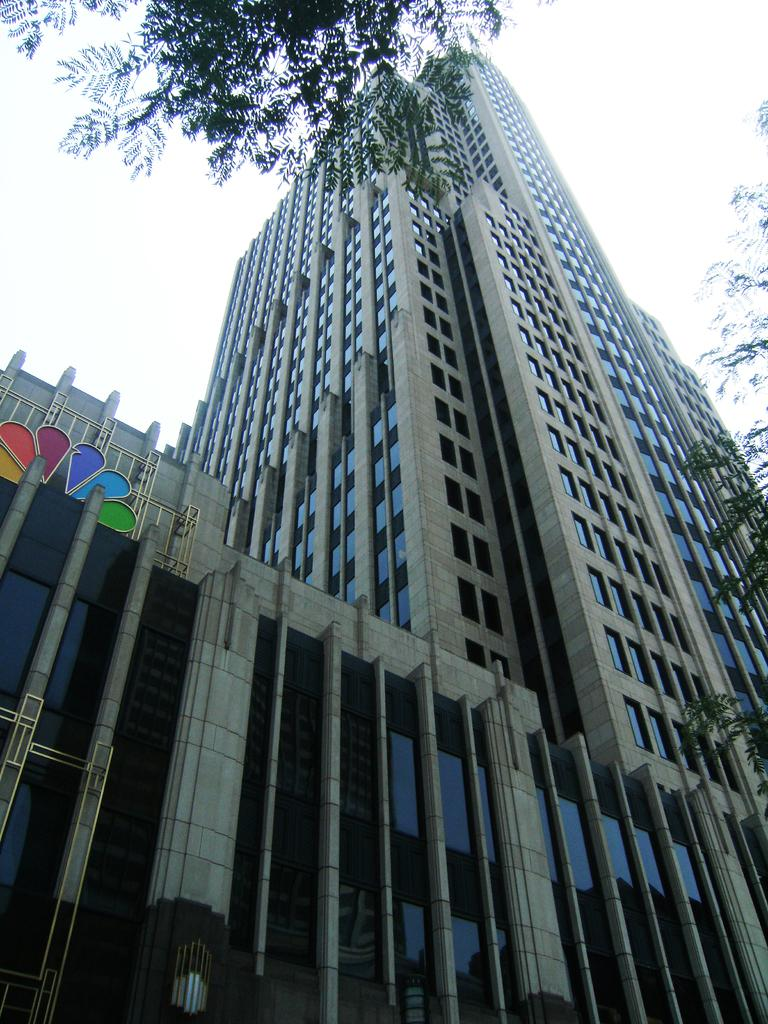What type of structure is the main subject in the image? There is a tower building in the image. Are there any other objects or features near the tower building? Yes, there are trees beside the tower building in the image. What type of property does the governor own near the lake in the image? There is no lake, property, or governor mentioned in the image. 